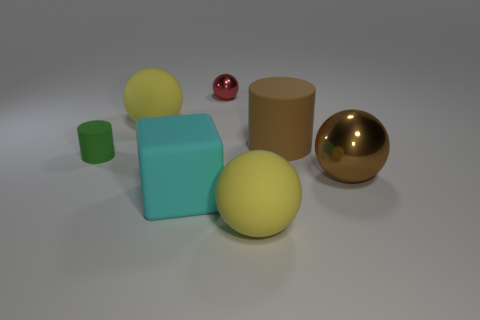There is a small green thing that is the same shape as the big brown matte object; what is its material?
Keep it short and to the point. Rubber. The tiny green rubber object has what shape?
Your answer should be compact. Cylinder. Are there any small shiny spheres that have the same color as the small cylinder?
Offer a terse response. No. Is the number of yellow matte balls left of the small metal sphere greater than the number of purple rubber objects?
Make the answer very short. Yes. There is a tiny green thing; is it the same shape as the big yellow object behind the big matte cube?
Your answer should be compact. No. Is there a rubber thing?
Your answer should be very brief. Yes. How many small things are cyan rubber things or metal blocks?
Provide a succinct answer. 0. Is the number of big brown rubber objects that are on the left side of the big cube greater than the number of yellow spheres behind the brown matte thing?
Make the answer very short. No. Do the big cyan thing and the tiny thing that is to the right of the tiny cylinder have the same material?
Your answer should be compact. No. The small cylinder has what color?
Keep it short and to the point. Green. 